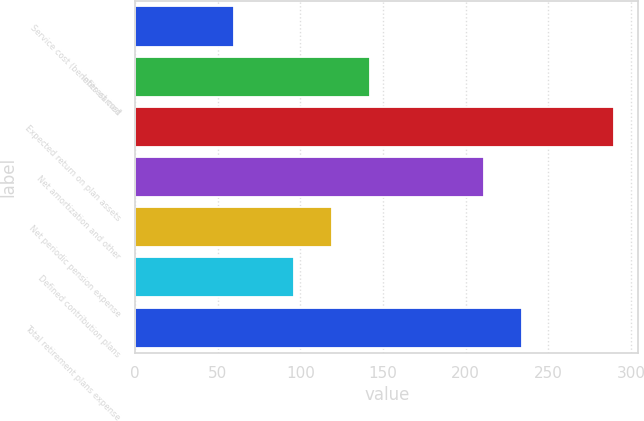<chart> <loc_0><loc_0><loc_500><loc_500><bar_chart><fcel>Service cost (benefits earned<fcel>Interest cost<fcel>Expected return on plan assets<fcel>Net amortization and other<fcel>Net periodic pension expense<fcel>Defined contribution plans<fcel>Total retirement plans expense<nl><fcel>60<fcel>142<fcel>290<fcel>211<fcel>119<fcel>96<fcel>234<nl></chart> 